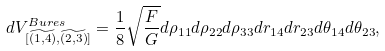<formula> <loc_0><loc_0><loc_500><loc_500>d V ^ { B u r e s } _ { [ \widetilde { ( 1 , 4 ) } , \widetilde { ( 2 , 3 ) } ] } = \frac { 1 } { 8 } \sqrt { \frac { F } { G } } d \rho _ { 1 1 } d \rho _ { 2 2 } d \rho _ { 3 3 } d r _ { 1 4 } d r _ { 2 3 } d \theta _ { 1 4 } d \theta _ { 2 3 } ,</formula> 